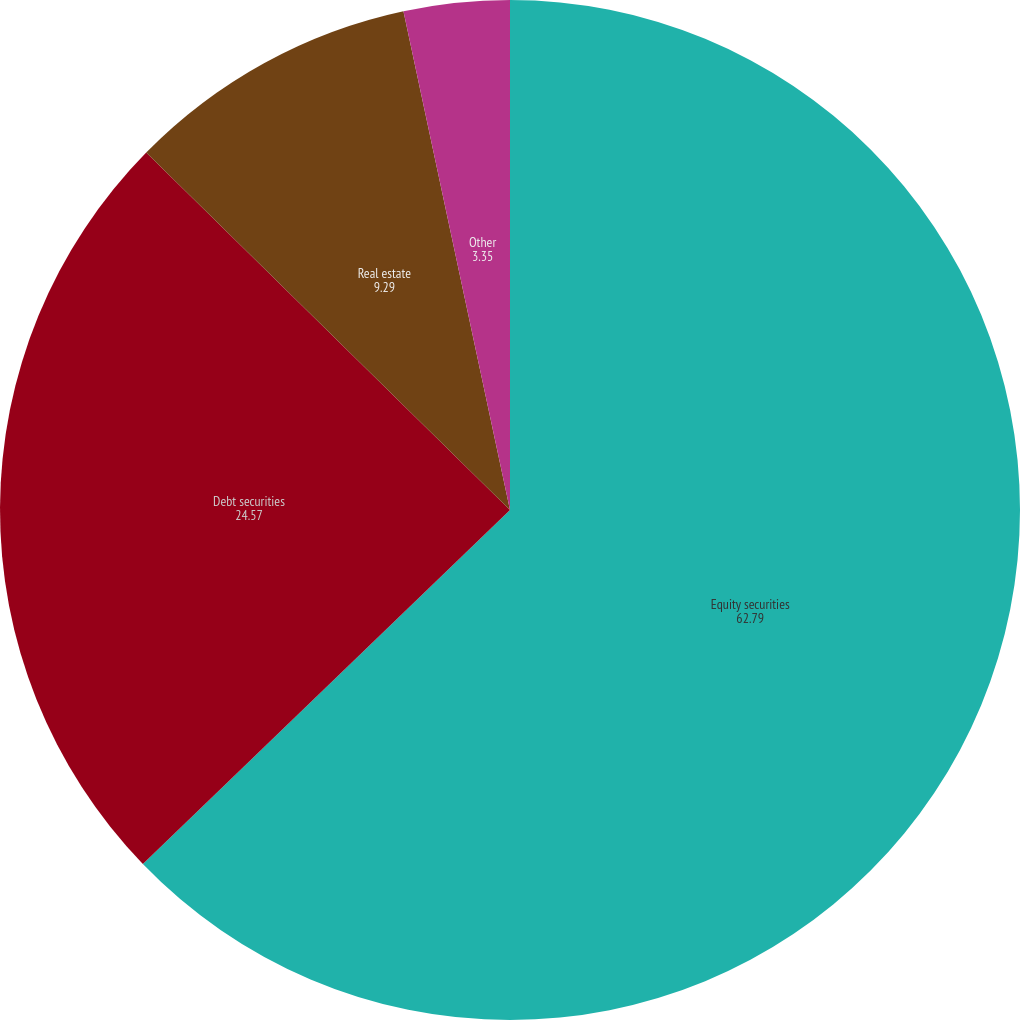<chart> <loc_0><loc_0><loc_500><loc_500><pie_chart><fcel>Equity securities<fcel>Debt securities<fcel>Real estate<fcel>Other<nl><fcel>62.79%<fcel>24.57%<fcel>9.29%<fcel>3.35%<nl></chart> 